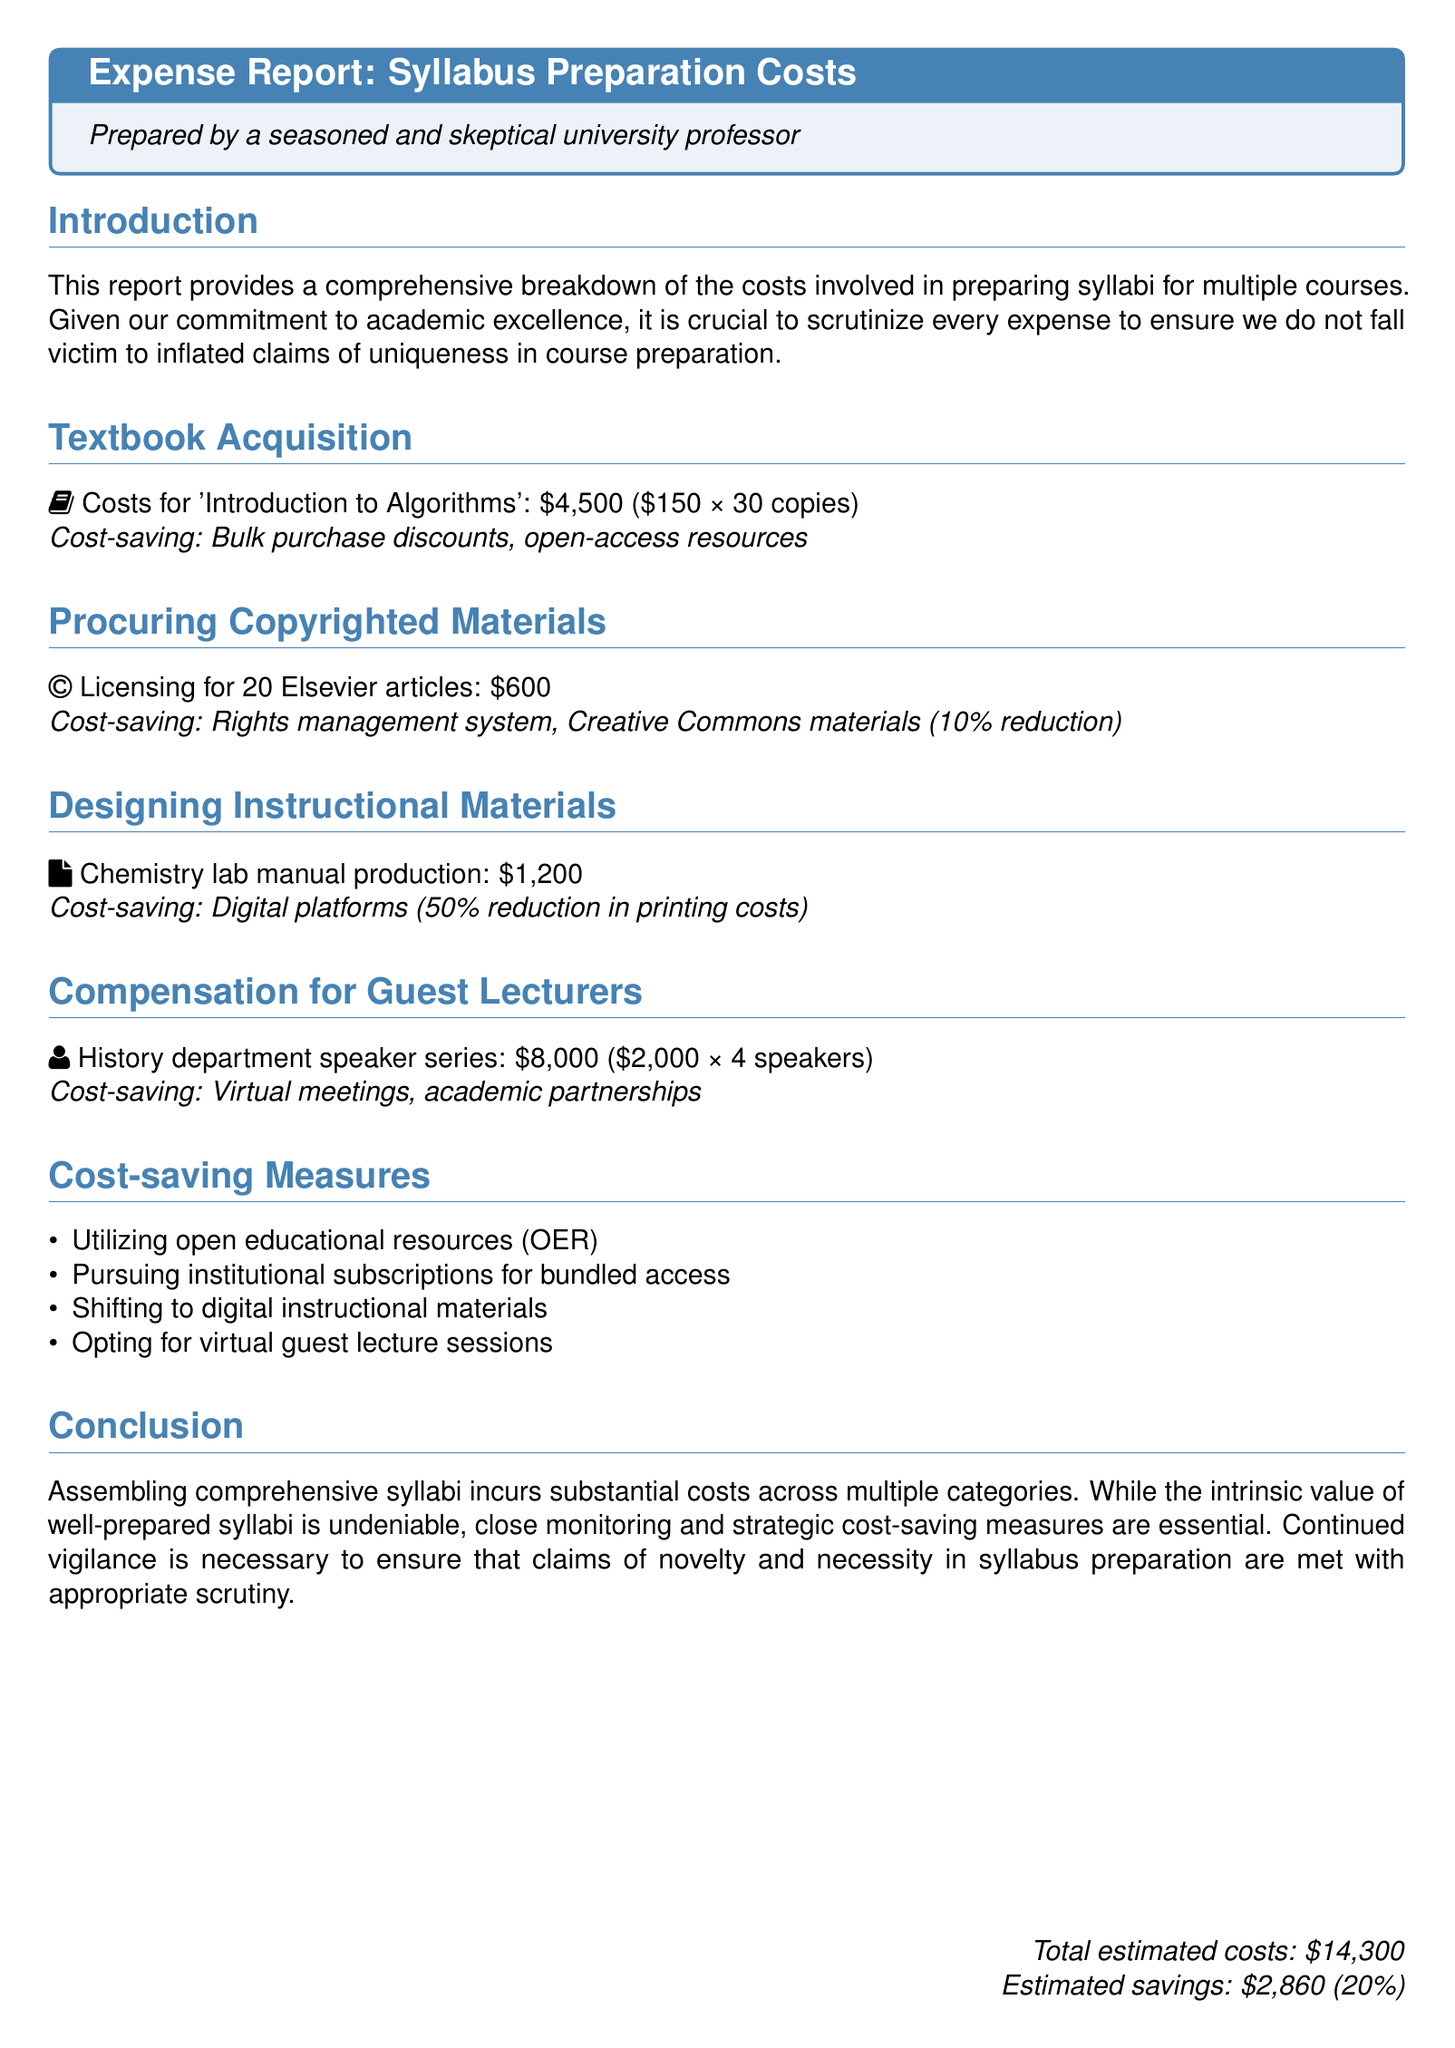What is the total estimated cost? The total estimated cost is provided at the end of the document, listed as \$14,300.
Answer: \$14,300 How much was spent on textbook acquisition? The expense report shows that \$4,500 was spent specifically on textbook acquisition for 'Introduction to Algorithms.'
Answer: \$4,500 What percentage reduction was achieved through the use of Creative Commons materials? The document mentions a 10% reduction in licensing costs due to the use of Creative Commons materials.
Answer: 10% What was the cost of the Chemistry lab manual production? The document specifies that the cost for producing the Chemistry lab manual was \$1,200.
Answer: \$1,200 How many guest lecturers were compensated in total? The report indicates a total of 4 guest lecturers were compensated for the speaker series.
Answer: 4 What is one of the cost-saving measures mentioned in the report? The report lists various cost-saving measures, one of which is utilizing open educational resources (OER).
Answer: Utilizing open educational resources (OER) What is the estimated savings stated in the report? The document concludes with an estimated savings amount of \$2,860.
Answer: \$2,860 How many Elsevier articles were licensed? The report states that licensing was obtained for 20 Elsevier articles.
Answer: 20 What is the total cost allocated for guest lecturers? The report details that the total cost for guest lecturers is \$8,000.
Answer: \$8,000 